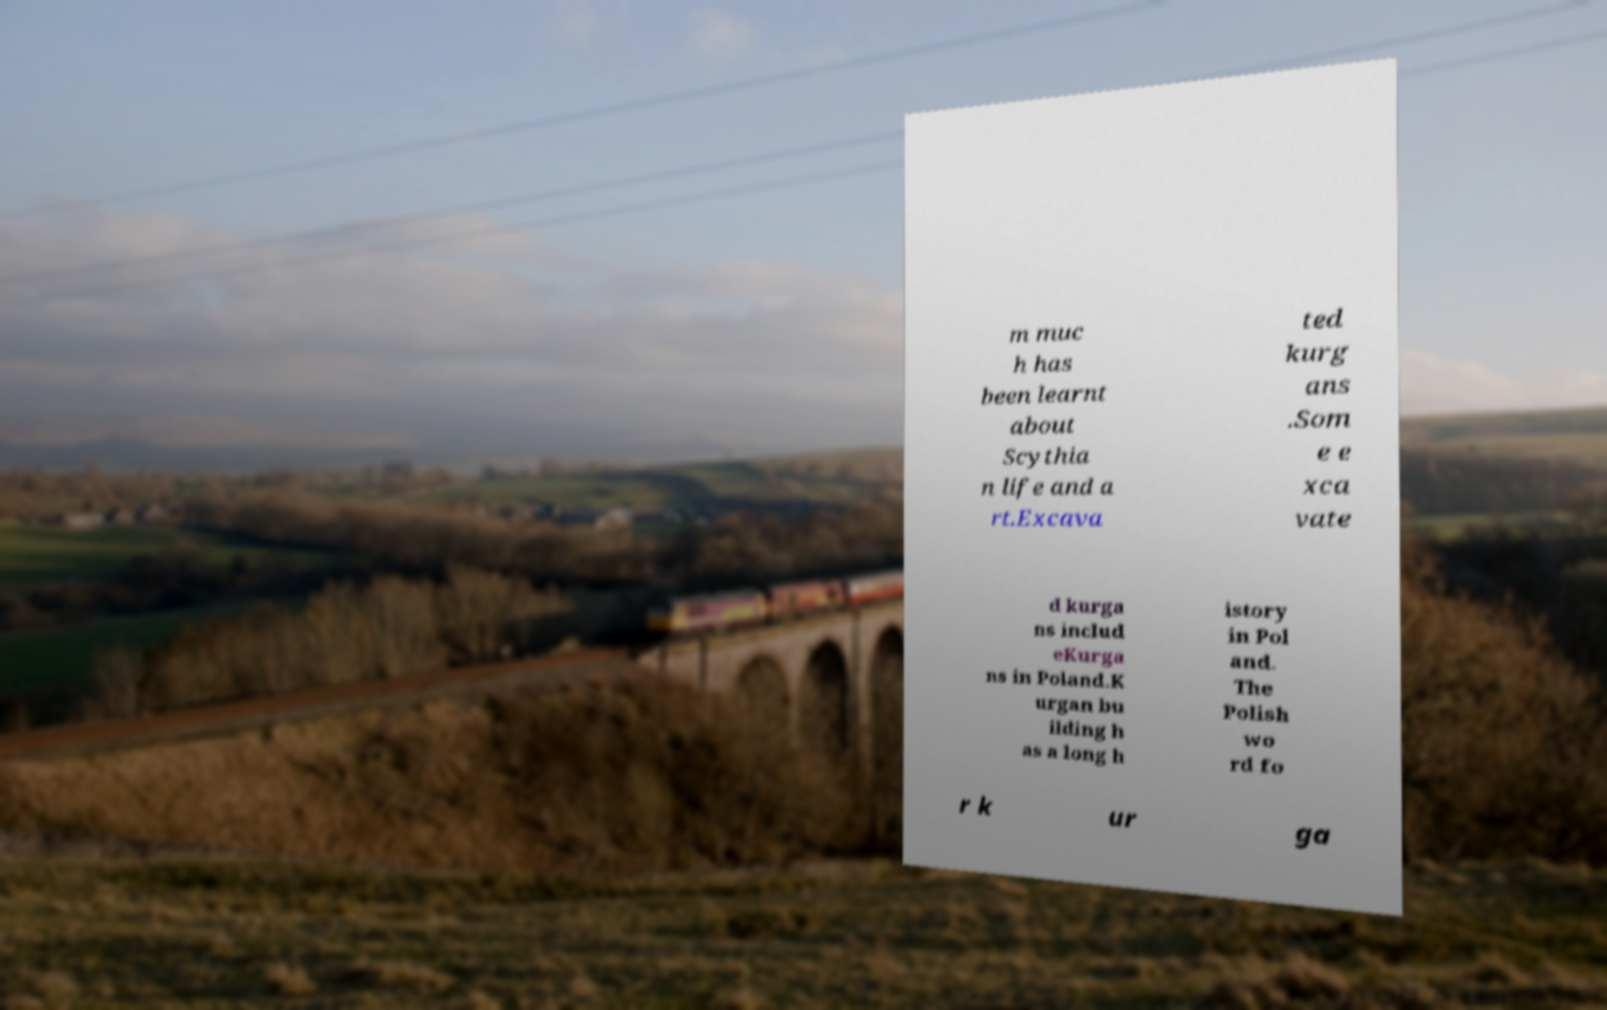Can you accurately transcribe the text from the provided image for me? m muc h has been learnt about Scythia n life and a rt.Excava ted kurg ans .Som e e xca vate d kurga ns includ eKurga ns in Poland.K urgan bu ilding h as a long h istory in Pol and. The Polish wo rd fo r k ur ga 